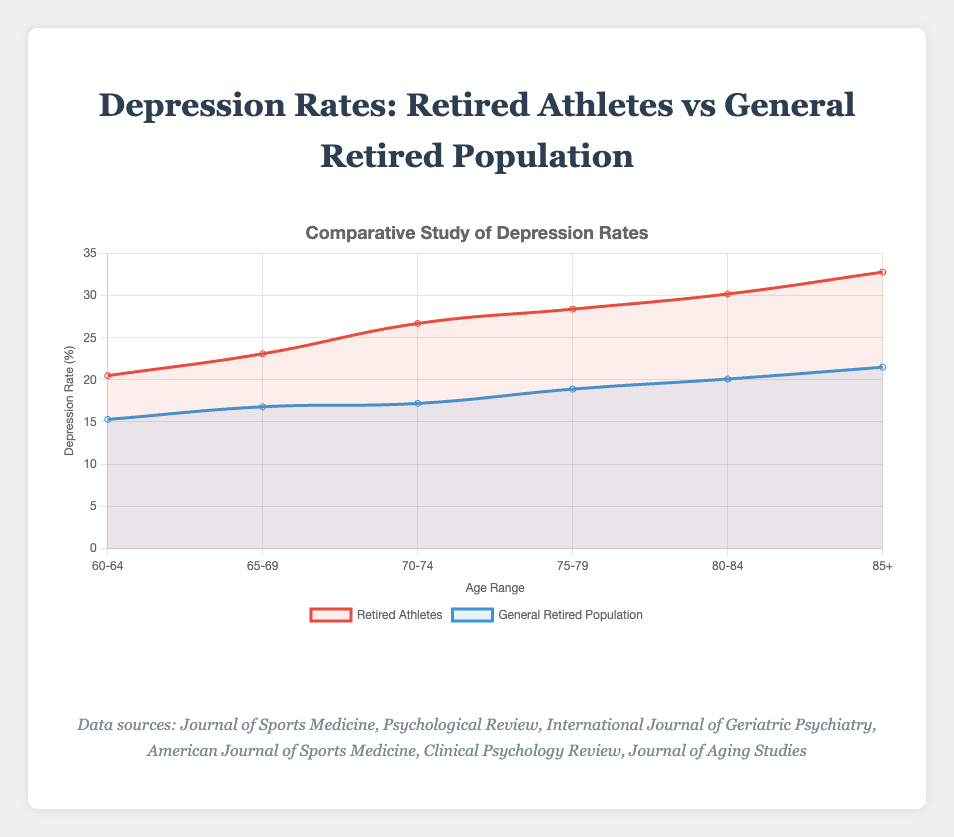What is the depression rate for retired athletes aged 70-74 according to the figure? According to the visual data, the line representing retired athletes intersects the age range 70-74 with a depression rate of 26.7%. This information can be directly read from the plot.
Answer: 26.7% What is the difference in depression rates between retired athletes and the general retired population in the 85+ age range? The depression rate for retired athletes in the 85+ age range is 32.8%, and for the general retired population, it is 21.5%. The difference can be calculated as 32.8% - 21.5% = 11.3%.
Answer: 11.3% In which age range is the gap between the depression rates of retired athletes and the general retired population the smallest? By visually comparing the differences across all age ranges, the smallest difference is observed in the 75-79 age range where the rates are 28.4% for retired athletes and 18.9% for the general retired population, making the difference 9.5%.
Answer: 75-79 Which group shows a greater increase in depression rates between ages 60-64 and 80-84, retired athletes or the general retired population? The depression rate for retired athletes increases from 20.5% to 30.2%, a difference of 9.7%. For the general retired population, it increases from 15.3% to 20.1%, a difference of 4.8%. Therefore, retired athletes show a greater increase.
Answer: Retired athletes What is the average depression rate for the general retired population across all age ranges? The depression rates can be averaged by summing the rates (15.3 + 16.8 + 17.2 + 18.9 + 20.1 + 21.5) = 109.8 and then dividing by the number of age ranges (6), resulting in an average of 109.8 / 6 = 18.3%.
Answer: 18.3% If the trend continues, what might be the expected depression rate for retired athletes aged 90+? Observing the increasing trend in depression rates for retired athletes, one can estimate the next value by considering the approximate increase per age range. From 80-84 to 85+, the increase is 32.8% - 30.2% = 2.6%. Adding this increase to the 85+ range yields 32.8% + 2.6% = 35.4%.
Answer: 35.4% Which age group has the highest depression rate for both retired athletes and the general retired population in the figure? The highest depression rate for both groups is seen in the 85+ age range, where the rates are 32.8% for retired athletes and 21.5% for the general retired population.
Answer: 85+ Is there an age range where the depression rate for the general retired population exceeds 20%? Upon examination of the y-values for the general retired population in each age range, the only range where the rate exceeds 20% is the 85+ range, which stands at 21.5%.
Answer: 85+ By how much does the depression rate gap between the two groups (retired athletes and general retired) change from age range 60-64 to age range 70-74? In the 60-64 age range, the difference in depression rates is 20.5% - 15.3% = 5.2%. In the 70-74 age range, it is 26.7% - 17.2% = 9.5%. The change in the gap is thus 9.5% - 5.2% = 4.3%.
Answer: 4.3% What is the most significant visual difference between the two groups' depression rates on the plot? The most significant visual difference is the consistently higher depression rate line (in red) for retired athletes compared to the blue line for the general retired population across all age ranges.
Answer: Higher lines for retired athletes in red 